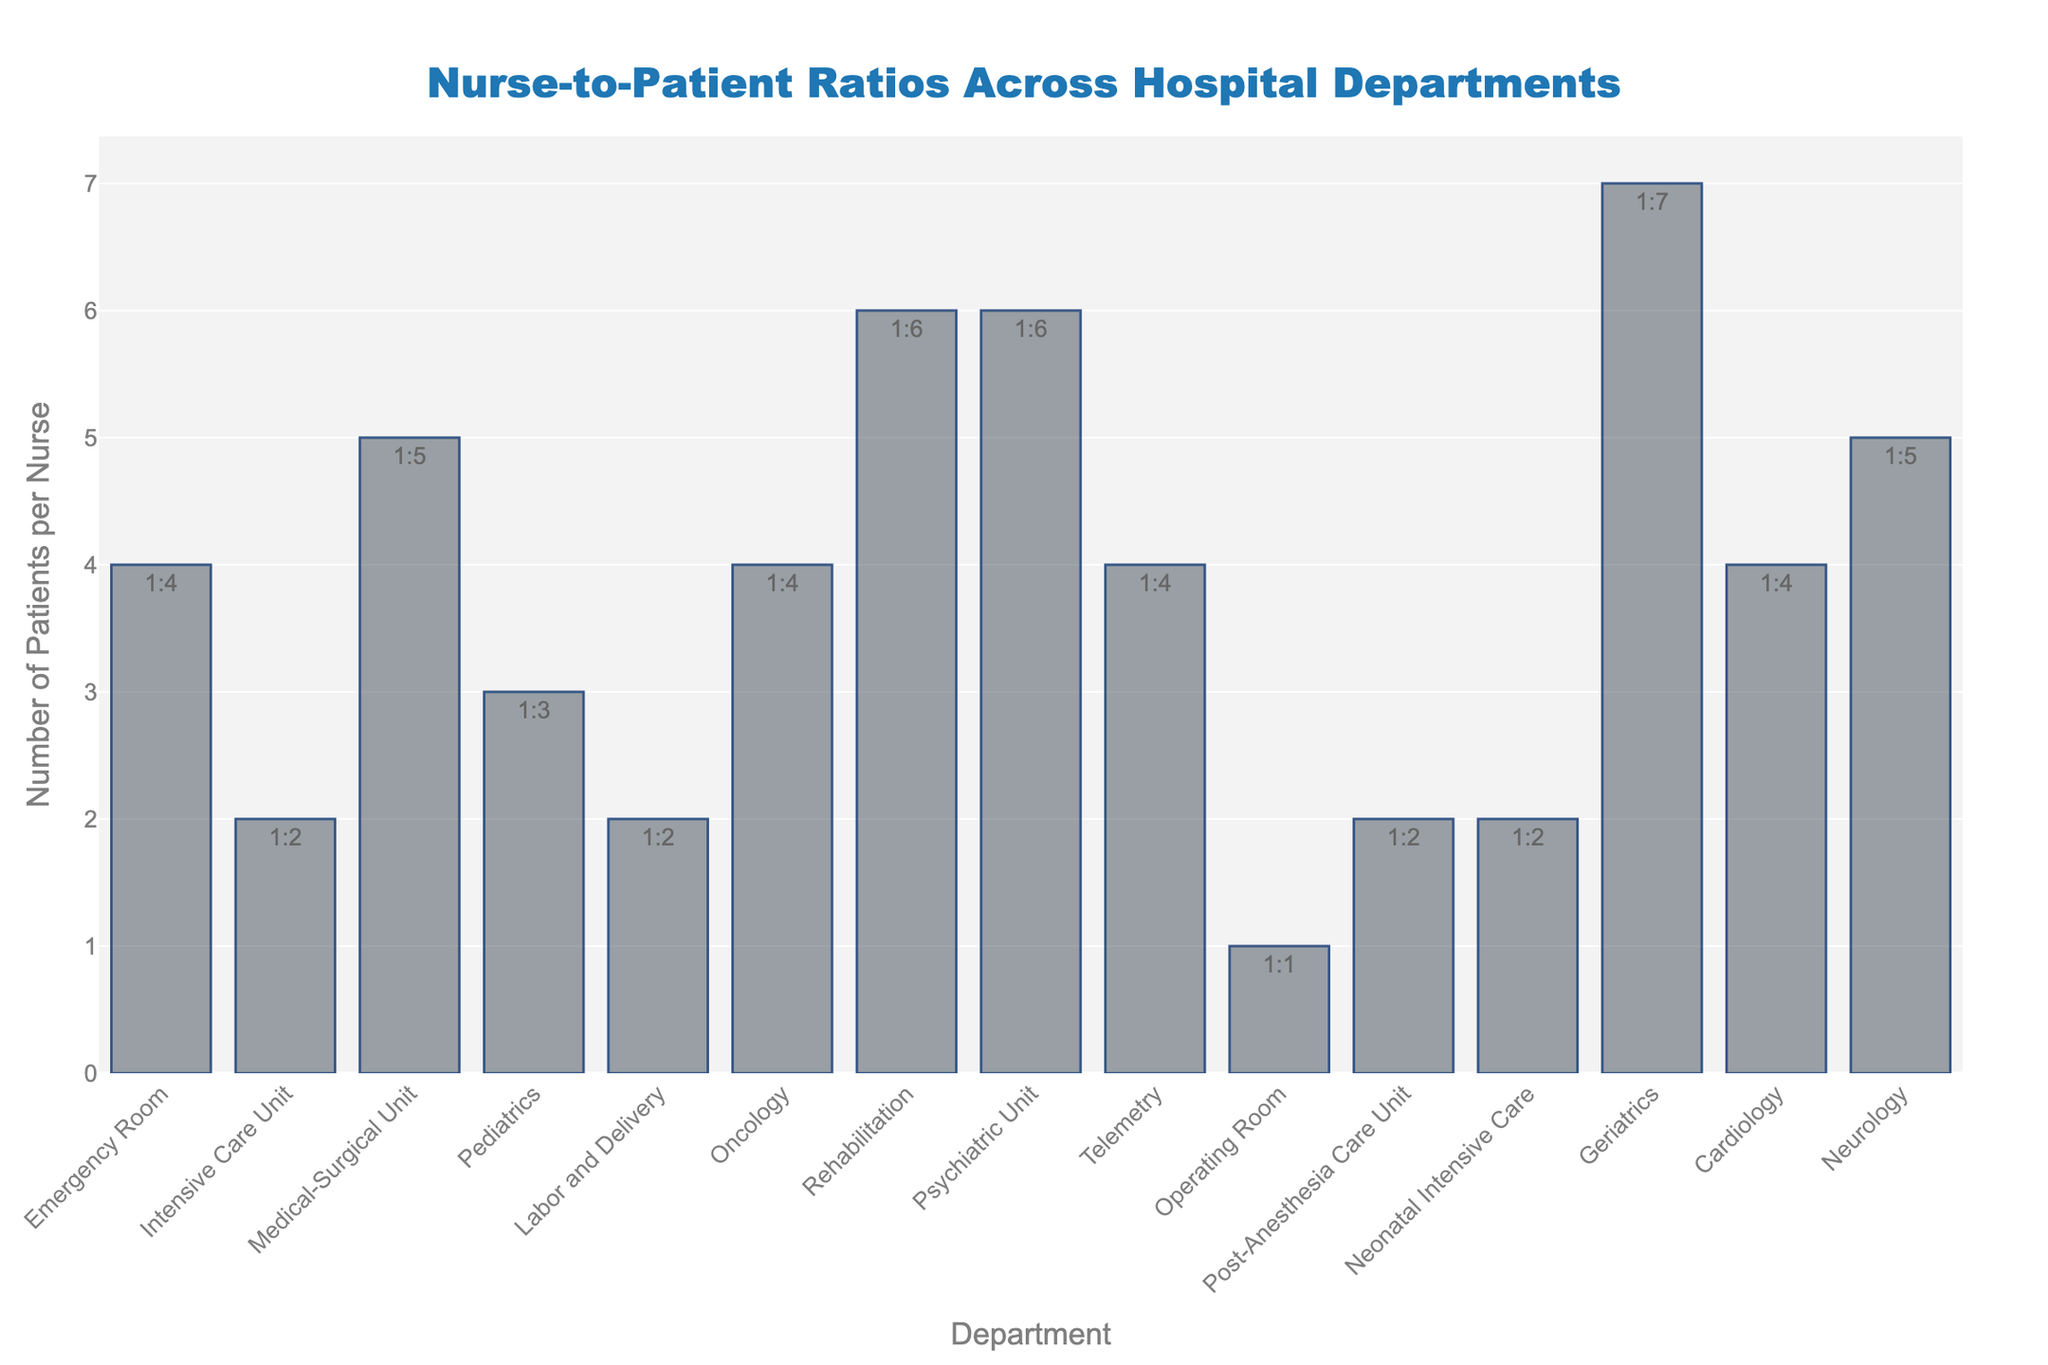Which department has the highest nurse-to-patient ratio? The bar for the Geriatrics department reaches the highest value on the y-axis with a ratio of 1:7.
Answer: Geriatrics Which departments have a nurse-to-patient ratio of 1:2? The departments listed with a ratio of 1:2 are Intensive Care Unit, Labor and Delivery, Post-Anesthesia Care Unit, and Neonatal Intensive Care.
Answer: Intensive Care Unit, Labor and Delivery, Post-Anesthesia Care Unit, and Neonatal Intensive Care What is the difference in the nurse-to-patient ratio between the Medical-Surgical Unit and the Operating Room? The nurse-to-patient ratio for the Medical-Surgical Unit is 1:5 and for the Operating Room is 1:1. The difference is calculated as 5 - 1 = 4.
Answer: 4 Which department has the lowest number of patients per nurse? The bar for the Operating Room department reaches the lowest value on the y-axis with a ratio of 1:1.
Answer: Operating Room How many departments have a nurse-to-patient ratio greater than 1:5? Identifying and counting the departments with a ratio greater than 1:5 reveals that Geriatrics is the only department with a nurse-to-patient ratio of 1:7.
Answer: 1 Is there a significant difference in nurse-to-patient ratios between Pediatrics and Oncology? The ratio for both Pediatrics and Oncology is evident from their bars, which indicate 1:3 for Pediatrics and 1:4 for Oncology. The difference is 4 - 3 = 1.
Answer: 1 Among Pediatrics, Oncology, and Telemetry, which department has the highest nurse-to-patient ratio? Comparing the y-axis values for these departments, Oncology and Telemetry both have a ratio of 1:4, while Pediatrics has a ratio of 1:3. Therefore, Oncology and Telemetry have the highest ratio among the three.
Answer: Oncology and Telemetry Which departments share the same nurse-to-patient ratio as the Emergency Room? Observing departments with the same y-axis height as Emergency Room (1:4) reveals that Oncology, Telemetry, and Cardiology share the same ratio.
Answer: Oncology, Telemetry, and Cardiology What is the combined nurse-to-patient ratio of the Intensive Care Unit and Labor and Delivery? Both departments have a ratio of 1:2. To find the combined ratio, we can sum up the number of patients per nurse, resulting in 2 + 2 = 4, forming a combined ratio of 1:4.
Answer: 1:4 What is the average nurse-to-patient ratio for the Rehabilitation and Psychiatric Unit departments? Both departments have a ratio of 1:6. The average ratio remains 1:6 since both have the same value.
Answer: 1:6 